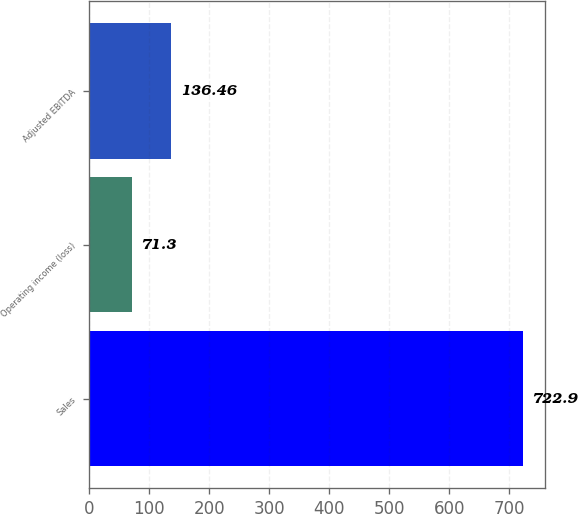Convert chart to OTSL. <chart><loc_0><loc_0><loc_500><loc_500><bar_chart><fcel>Sales<fcel>Operating income (loss)<fcel>Adjusted EBITDA<nl><fcel>722.9<fcel>71.3<fcel>136.46<nl></chart> 